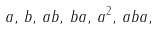<formula> <loc_0><loc_0><loc_500><loc_500>a , \, b , \, a b , \, b a , \, a ^ { 2 } , \, a b a ,</formula> 